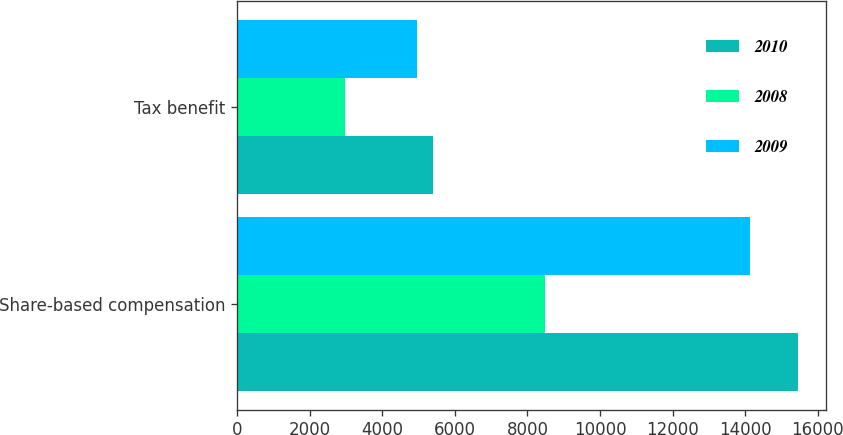Convert chart to OTSL. <chart><loc_0><loc_0><loc_500><loc_500><stacked_bar_chart><ecel><fcel>Share-based compensation<fcel>Tax benefit<nl><fcel>2010<fcel>15453<fcel>5408<nl><fcel>2008<fcel>8492<fcel>2972<nl><fcel>2009<fcel>14142<fcel>4950<nl></chart> 